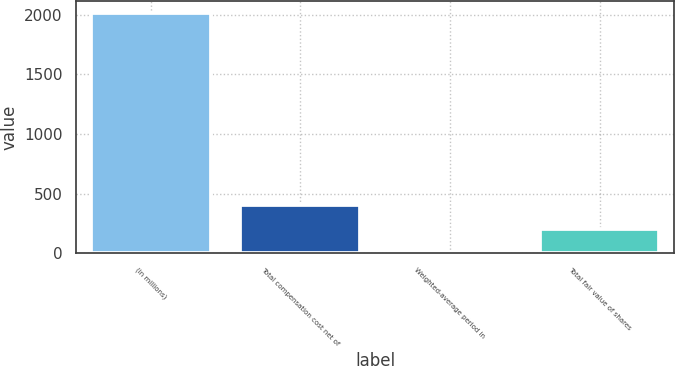<chart> <loc_0><loc_0><loc_500><loc_500><bar_chart><fcel>(in millions)<fcel>Total compensation cost net of<fcel>Weighted-average period in<fcel>Total fair value of shares<nl><fcel>2016<fcel>404.8<fcel>2<fcel>203.4<nl></chart> 